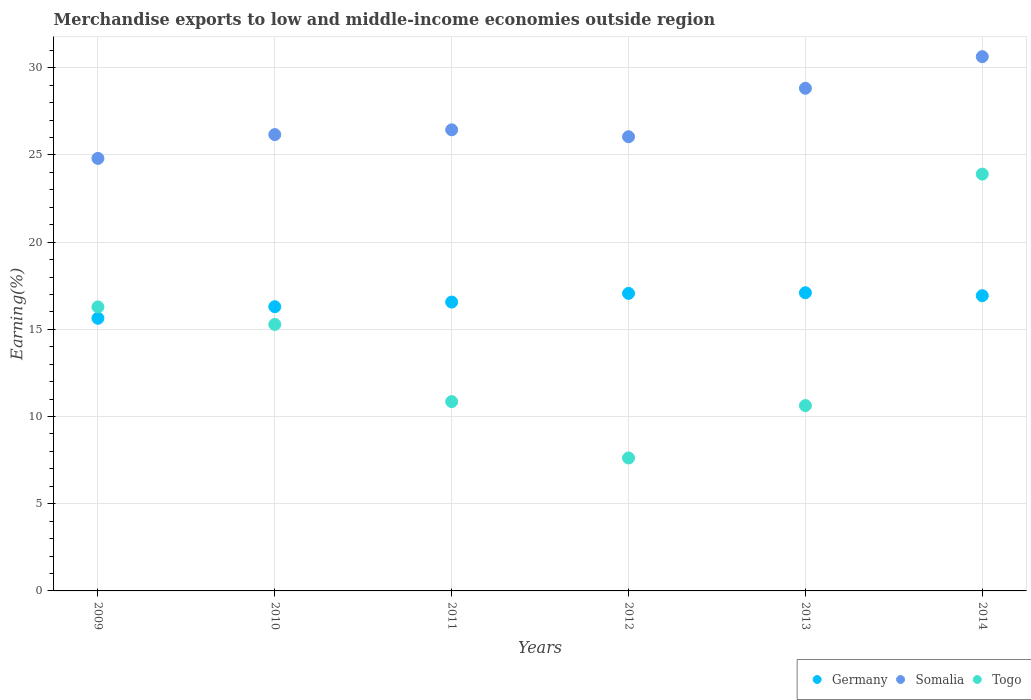How many different coloured dotlines are there?
Your answer should be very brief. 3. What is the percentage of amount earned from merchandise exports in Togo in 2012?
Your answer should be compact. 7.62. Across all years, what is the maximum percentage of amount earned from merchandise exports in Togo?
Give a very brief answer. 23.9. Across all years, what is the minimum percentage of amount earned from merchandise exports in Somalia?
Offer a very short reply. 24.8. In which year was the percentage of amount earned from merchandise exports in Somalia maximum?
Provide a short and direct response. 2014. In which year was the percentage of amount earned from merchandise exports in Togo minimum?
Provide a succinct answer. 2012. What is the total percentage of amount earned from merchandise exports in Somalia in the graph?
Give a very brief answer. 162.92. What is the difference between the percentage of amount earned from merchandise exports in Germany in 2010 and that in 2011?
Offer a terse response. -0.27. What is the difference between the percentage of amount earned from merchandise exports in Togo in 2014 and the percentage of amount earned from merchandise exports in Germany in 2012?
Make the answer very short. 6.84. What is the average percentage of amount earned from merchandise exports in Somalia per year?
Provide a short and direct response. 27.15. In the year 2009, what is the difference between the percentage of amount earned from merchandise exports in Germany and percentage of amount earned from merchandise exports in Togo?
Keep it short and to the point. -0.65. In how many years, is the percentage of amount earned from merchandise exports in Togo greater than 10 %?
Your answer should be very brief. 5. What is the ratio of the percentage of amount earned from merchandise exports in Germany in 2011 to that in 2013?
Ensure brevity in your answer.  0.97. Is the percentage of amount earned from merchandise exports in Germany in 2010 less than that in 2012?
Keep it short and to the point. Yes. Is the difference between the percentage of amount earned from merchandise exports in Germany in 2012 and 2013 greater than the difference between the percentage of amount earned from merchandise exports in Togo in 2012 and 2013?
Provide a short and direct response. Yes. What is the difference between the highest and the second highest percentage of amount earned from merchandise exports in Somalia?
Your answer should be compact. 1.81. What is the difference between the highest and the lowest percentage of amount earned from merchandise exports in Somalia?
Your response must be concise. 5.83. Is the sum of the percentage of amount earned from merchandise exports in Togo in 2010 and 2011 greater than the maximum percentage of amount earned from merchandise exports in Somalia across all years?
Provide a succinct answer. No. Is it the case that in every year, the sum of the percentage of amount earned from merchandise exports in Somalia and percentage of amount earned from merchandise exports in Germany  is greater than the percentage of amount earned from merchandise exports in Togo?
Give a very brief answer. Yes. Is the percentage of amount earned from merchandise exports in Germany strictly greater than the percentage of amount earned from merchandise exports in Somalia over the years?
Your answer should be compact. No. How many dotlines are there?
Your answer should be compact. 3. What is the difference between two consecutive major ticks on the Y-axis?
Ensure brevity in your answer.  5. Are the values on the major ticks of Y-axis written in scientific E-notation?
Your answer should be compact. No. Does the graph contain any zero values?
Provide a succinct answer. No. Does the graph contain grids?
Keep it short and to the point. Yes. Where does the legend appear in the graph?
Offer a terse response. Bottom right. What is the title of the graph?
Provide a succinct answer. Merchandise exports to low and middle-income economies outside region. What is the label or title of the Y-axis?
Provide a short and direct response. Earning(%). What is the Earning(%) of Germany in 2009?
Offer a very short reply. 15.63. What is the Earning(%) of Somalia in 2009?
Offer a terse response. 24.8. What is the Earning(%) of Togo in 2009?
Make the answer very short. 16.29. What is the Earning(%) in Germany in 2010?
Provide a succinct answer. 16.3. What is the Earning(%) of Somalia in 2010?
Give a very brief answer. 26.17. What is the Earning(%) of Togo in 2010?
Offer a terse response. 15.28. What is the Earning(%) in Germany in 2011?
Your response must be concise. 16.56. What is the Earning(%) of Somalia in 2011?
Make the answer very short. 26.44. What is the Earning(%) in Togo in 2011?
Make the answer very short. 10.85. What is the Earning(%) of Germany in 2012?
Offer a very short reply. 17.06. What is the Earning(%) in Somalia in 2012?
Ensure brevity in your answer.  26.04. What is the Earning(%) of Togo in 2012?
Ensure brevity in your answer.  7.62. What is the Earning(%) of Germany in 2013?
Provide a succinct answer. 17.1. What is the Earning(%) in Somalia in 2013?
Your answer should be very brief. 28.82. What is the Earning(%) of Togo in 2013?
Provide a short and direct response. 10.63. What is the Earning(%) of Germany in 2014?
Make the answer very short. 16.93. What is the Earning(%) in Somalia in 2014?
Keep it short and to the point. 30.64. What is the Earning(%) of Togo in 2014?
Give a very brief answer. 23.9. Across all years, what is the maximum Earning(%) in Germany?
Give a very brief answer. 17.1. Across all years, what is the maximum Earning(%) in Somalia?
Keep it short and to the point. 30.64. Across all years, what is the maximum Earning(%) in Togo?
Your response must be concise. 23.9. Across all years, what is the minimum Earning(%) of Germany?
Keep it short and to the point. 15.63. Across all years, what is the minimum Earning(%) in Somalia?
Provide a succinct answer. 24.8. Across all years, what is the minimum Earning(%) of Togo?
Offer a very short reply. 7.62. What is the total Earning(%) in Germany in the graph?
Give a very brief answer. 99.59. What is the total Earning(%) of Somalia in the graph?
Provide a short and direct response. 162.92. What is the total Earning(%) in Togo in the graph?
Offer a very short reply. 84.58. What is the difference between the Earning(%) in Germany in 2009 and that in 2010?
Your response must be concise. -0.66. What is the difference between the Earning(%) of Somalia in 2009 and that in 2010?
Offer a terse response. -1.37. What is the difference between the Earning(%) of Togo in 2009 and that in 2010?
Your response must be concise. 1. What is the difference between the Earning(%) of Germany in 2009 and that in 2011?
Offer a terse response. -0.93. What is the difference between the Earning(%) of Somalia in 2009 and that in 2011?
Make the answer very short. -1.64. What is the difference between the Earning(%) in Togo in 2009 and that in 2011?
Offer a terse response. 5.43. What is the difference between the Earning(%) in Germany in 2009 and that in 2012?
Make the answer very short. -1.43. What is the difference between the Earning(%) of Somalia in 2009 and that in 2012?
Provide a succinct answer. -1.24. What is the difference between the Earning(%) of Togo in 2009 and that in 2012?
Offer a very short reply. 8.66. What is the difference between the Earning(%) in Germany in 2009 and that in 2013?
Keep it short and to the point. -1.46. What is the difference between the Earning(%) in Somalia in 2009 and that in 2013?
Ensure brevity in your answer.  -4.02. What is the difference between the Earning(%) in Togo in 2009 and that in 2013?
Ensure brevity in your answer.  5.66. What is the difference between the Earning(%) in Germany in 2009 and that in 2014?
Offer a very short reply. -1.3. What is the difference between the Earning(%) in Somalia in 2009 and that in 2014?
Keep it short and to the point. -5.83. What is the difference between the Earning(%) in Togo in 2009 and that in 2014?
Ensure brevity in your answer.  -7.61. What is the difference between the Earning(%) of Germany in 2010 and that in 2011?
Provide a succinct answer. -0.27. What is the difference between the Earning(%) in Somalia in 2010 and that in 2011?
Keep it short and to the point. -0.27. What is the difference between the Earning(%) of Togo in 2010 and that in 2011?
Provide a succinct answer. 4.43. What is the difference between the Earning(%) in Germany in 2010 and that in 2012?
Your response must be concise. -0.76. What is the difference between the Earning(%) in Somalia in 2010 and that in 2012?
Offer a very short reply. 0.12. What is the difference between the Earning(%) of Togo in 2010 and that in 2012?
Provide a short and direct response. 7.66. What is the difference between the Earning(%) in Germany in 2010 and that in 2013?
Offer a very short reply. -0.8. What is the difference between the Earning(%) of Somalia in 2010 and that in 2013?
Your response must be concise. -2.66. What is the difference between the Earning(%) in Togo in 2010 and that in 2013?
Give a very brief answer. 4.65. What is the difference between the Earning(%) of Germany in 2010 and that in 2014?
Ensure brevity in your answer.  -0.63. What is the difference between the Earning(%) of Somalia in 2010 and that in 2014?
Provide a short and direct response. -4.47. What is the difference between the Earning(%) of Togo in 2010 and that in 2014?
Make the answer very short. -8.62. What is the difference between the Earning(%) of Germany in 2011 and that in 2012?
Ensure brevity in your answer.  -0.5. What is the difference between the Earning(%) in Somalia in 2011 and that in 2012?
Offer a terse response. 0.4. What is the difference between the Earning(%) of Togo in 2011 and that in 2012?
Your answer should be very brief. 3.23. What is the difference between the Earning(%) in Germany in 2011 and that in 2013?
Ensure brevity in your answer.  -0.54. What is the difference between the Earning(%) of Somalia in 2011 and that in 2013?
Provide a short and direct response. -2.38. What is the difference between the Earning(%) in Togo in 2011 and that in 2013?
Your answer should be very brief. 0.23. What is the difference between the Earning(%) of Germany in 2011 and that in 2014?
Your answer should be very brief. -0.37. What is the difference between the Earning(%) of Somalia in 2011 and that in 2014?
Make the answer very short. -4.2. What is the difference between the Earning(%) of Togo in 2011 and that in 2014?
Offer a very short reply. -13.05. What is the difference between the Earning(%) of Germany in 2012 and that in 2013?
Your answer should be compact. -0.04. What is the difference between the Earning(%) of Somalia in 2012 and that in 2013?
Ensure brevity in your answer.  -2.78. What is the difference between the Earning(%) in Togo in 2012 and that in 2013?
Make the answer very short. -3.01. What is the difference between the Earning(%) of Germany in 2012 and that in 2014?
Provide a short and direct response. 0.13. What is the difference between the Earning(%) in Somalia in 2012 and that in 2014?
Your answer should be very brief. -4.59. What is the difference between the Earning(%) of Togo in 2012 and that in 2014?
Your answer should be compact. -16.28. What is the difference between the Earning(%) of Germany in 2013 and that in 2014?
Your answer should be very brief. 0.17. What is the difference between the Earning(%) of Somalia in 2013 and that in 2014?
Give a very brief answer. -1.81. What is the difference between the Earning(%) of Togo in 2013 and that in 2014?
Provide a succinct answer. -13.27. What is the difference between the Earning(%) of Germany in 2009 and the Earning(%) of Somalia in 2010?
Your response must be concise. -10.53. What is the difference between the Earning(%) of Germany in 2009 and the Earning(%) of Togo in 2010?
Your answer should be very brief. 0.35. What is the difference between the Earning(%) of Somalia in 2009 and the Earning(%) of Togo in 2010?
Your answer should be very brief. 9.52. What is the difference between the Earning(%) in Germany in 2009 and the Earning(%) in Somalia in 2011?
Give a very brief answer. -10.81. What is the difference between the Earning(%) of Germany in 2009 and the Earning(%) of Togo in 2011?
Your answer should be very brief. 4.78. What is the difference between the Earning(%) of Somalia in 2009 and the Earning(%) of Togo in 2011?
Give a very brief answer. 13.95. What is the difference between the Earning(%) of Germany in 2009 and the Earning(%) of Somalia in 2012?
Ensure brevity in your answer.  -10.41. What is the difference between the Earning(%) of Germany in 2009 and the Earning(%) of Togo in 2012?
Make the answer very short. 8.01. What is the difference between the Earning(%) in Somalia in 2009 and the Earning(%) in Togo in 2012?
Offer a very short reply. 17.18. What is the difference between the Earning(%) in Germany in 2009 and the Earning(%) in Somalia in 2013?
Ensure brevity in your answer.  -13.19. What is the difference between the Earning(%) of Germany in 2009 and the Earning(%) of Togo in 2013?
Provide a succinct answer. 5.01. What is the difference between the Earning(%) in Somalia in 2009 and the Earning(%) in Togo in 2013?
Keep it short and to the point. 14.17. What is the difference between the Earning(%) in Germany in 2009 and the Earning(%) in Somalia in 2014?
Offer a very short reply. -15. What is the difference between the Earning(%) of Germany in 2009 and the Earning(%) of Togo in 2014?
Provide a succinct answer. -8.27. What is the difference between the Earning(%) in Somalia in 2009 and the Earning(%) in Togo in 2014?
Provide a short and direct response. 0.9. What is the difference between the Earning(%) of Germany in 2010 and the Earning(%) of Somalia in 2011?
Ensure brevity in your answer.  -10.14. What is the difference between the Earning(%) of Germany in 2010 and the Earning(%) of Togo in 2011?
Your answer should be very brief. 5.44. What is the difference between the Earning(%) of Somalia in 2010 and the Earning(%) of Togo in 2011?
Your answer should be very brief. 15.31. What is the difference between the Earning(%) of Germany in 2010 and the Earning(%) of Somalia in 2012?
Make the answer very short. -9.75. What is the difference between the Earning(%) of Germany in 2010 and the Earning(%) of Togo in 2012?
Offer a very short reply. 8.67. What is the difference between the Earning(%) in Somalia in 2010 and the Earning(%) in Togo in 2012?
Your answer should be compact. 18.54. What is the difference between the Earning(%) of Germany in 2010 and the Earning(%) of Somalia in 2013?
Your response must be concise. -12.53. What is the difference between the Earning(%) of Germany in 2010 and the Earning(%) of Togo in 2013?
Provide a succinct answer. 5.67. What is the difference between the Earning(%) of Somalia in 2010 and the Earning(%) of Togo in 2013?
Offer a terse response. 15.54. What is the difference between the Earning(%) in Germany in 2010 and the Earning(%) in Somalia in 2014?
Your response must be concise. -14.34. What is the difference between the Earning(%) in Germany in 2010 and the Earning(%) in Togo in 2014?
Keep it short and to the point. -7.6. What is the difference between the Earning(%) of Somalia in 2010 and the Earning(%) of Togo in 2014?
Ensure brevity in your answer.  2.27. What is the difference between the Earning(%) of Germany in 2011 and the Earning(%) of Somalia in 2012?
Give a very brief answer. -9.48. What is the difference between the Earning(%) in Germany in 2011 and the Earning(%) in Togo in 2012?
Offer a terse response. 8.94. What is the difference between the Earning(%) of Somalia in 2011 and the Earning(%) of Togo in 2012?
Your answer should be very brief. 18.82. What is the difference between the Earning(%) of Germany in 2011 and the Earning(%) of Somalia in 2013?
Give a very brief answer. -12.26. What is the difference between the Earning(%) in Germany in 2011 and the Earning(%) in Togo in 2013?
Offer a very short reply. 5.93. What is the difference between the Earning(%) in Somalia in 2011 and the Earning(%) in Togo in 2013?
Your response must be concise. 15.81. What is the difference between the Earning(%) in Germany in 2011 and the Earning(%) in Somalia in 2014?
Give a very brief answer. -14.07. What is the difference between the Earning(%) in Germany in 2011 and the Earning(%) in Togo in 2014?
Make the answer very short. -7.34. What is the difference between the Earning(%) of Somalia in 2011 and the Earning(%) of Togo in 2014?
Offer a very short reply. 2.54. What is the difference between the Earning(%) in Germany in 2012 and the Earning(%) in Somalia in 2013?
Give a very brief answer. -11.76. What is the difference between the Earning(%) of Germany in 2012 and the Earning(%) of Togo in 2013?
Provide a short and direct response. 6.43. What is the difference between the Earning(%) in Somalia in 2012 and the Earning(%) in Togo in 2013?
Your response must be concise. 15.42. What is the difference between the Earning(%) of Germany in 2012 and the Earning(%) of Somalia in 2014?
Give a very brief answer. -13.58. What is the difference between the Earning(%) of Germany in 2012 and the Earning(%) of Togo in 2014?
Provide a short and direct response. -6.84. What is the difference between the Earning(%) of Somalia in 2012 and the Earning(%) of Togo in 2014?
Give a very brief answer. 2.14. What is the difference between the Earning(%) in Germany in 2013 and the Earning(%) in Somalia in 2014?
Your response must be concise. -13.54. What is the difference between the Earning(%) of Germany in 2013 and the Earning(%) of Togo in 2014?
Give a very brief answer. -6.8. What is the difference between the Earning(%) of Somalia in 2013 and the Earning(%) of Togo in 2014?
Your answer should be very brief. 4.92. What is the average Earning(%) of Germany per year?
Keep it short and to the point. 16.6. What is the average Earning(%) in Somalia per year?
Your answer should be very brief. 27.15. What is the average Earning(%) of Togo per year?
Your answer should be very brief. 14.1. In the year 2009, what is the difference between the Earning(%) in Germany and Earning(%) in Somalia?
Provide a succinct answer. -9.17. In the year 2009, what is the difference between the Earning(%) of Germany and Earning(%) of Togo?
Your answer should be very brief. -0.65. In the year 2009, what is the difference between the Earning(%) in Somalia and Earning(%) in Togo?
Ensure brevity in your answer.  8.52. In the year 2010, what is the difference between the Earning(%) in Germany and Earning(%) in Somalia?
Offer a terse response. -9.87. In the year 2010, what is the difference between the Earning(%) of Germany and Earning(%) of Togo?
Offer a terse response. 1.02. In the year 2010, what is the difference between the Earning(%) of Somalia and Earning(%) of Togo?
Your response must be concise. 10.89. In the year 2011, what is the difference between the Earning(%) of Germany and Earning(%) of Somalia?
Provide a short and direct response. -9.88. In the year 2011, what is the difference between the Earning(%) in Germany and Earning(%) in Togo?
Your answer should be compact. 5.71. In the year 2011, what is the difference between the Earning(%) in Somalia and Earning(%) in Togo?
Offer a terse response. 15.59. In the year 2012, what is the difference between the Earning(%) in Germany and Earning(%) in Somalia?
Make the answer very short. -8.98. In the year 2012, what is the difference between the Earning(%) of Germany and Earning(%) of Togo?
Offer a terse response. 9.44. In the year 2012, what is the difference between the Earning(%) of Somalia and Earning(%) of Togo?
Your response must be concise. 18.42. In the year 2013, what is the difference between the Earning(%) of Germany and Earning(%) of Somalia?
Provide a succinct answer. -11.72. In the year 2013, what is the difference between the Earning(%) in Germany and Earning(%) in Togo?
Your answer should be compact. 6.47. In the year 2013, what is the difference between the Earning(%) of Somalia and Earning(%) of Togo?
Your answer should be very brief. 18.19. In the year 2014, what is the difference between the Earning(%) of Germany and Earning(%) of Somalia?
Ensure brevity in your answer.  -13.71. In the year 2014, what is the difference between the Earning(%) in Germany and Earning(%) in Togo?
Ensure brevity in your answer.  -6.97. In the year 2014, what is the difference between the Earning(%) in Somalia and Earning(%) in Togo?
Give a very brief answer. 6.74. What is the ratio of the Earning(%) in Germany in 2009 to that in 2010?
Offer a very short reply. 0.96. What is the ratio of the Earning(%) in Somalia in 2009 to that in 2010?
Provide a succinct answer. 0.95. What is the ratio of the Earning(%) in Togo in 2009 to that in 2010?
Your answer should be very brief. 1.07. What is the ratio of the Earning(%) of Germany in 2009 to that in 2011?
Keep it short and to the point. 0.94. What is the ratio of the Earning(%) of Somalia in 2009 to that in 2011?
Give a very brief answer. 0.94. What is the ratio of the Earning(%) of Togo in 2009 to that in 2011?
Ensure brevity in your answer.  1.5. What is the ratio of the Earning(%) of Germany in 2009 to that in 2012?
Provide a succinct answer. 0.92. What is the ratio of the Earning(%) of Somalia in 2009 to that in 2012?
Provide a succinct answer. 0.95. What is the ratio of the Earning(%) in Togo in 2009 to that in 2012?
Offer a terse response. 2.14. What is the ratio of the Earning(%) in Germany in 2009 to that in 2013?
Keep it short and to the point. 0.91. What is the ratio of the Earning(%) of Somalia in 2009 to that in 2013?
Make the answer very short. 0.86. What is the ratio of the Earning(%) in Togo in 2009 to that in 2013?
Provide a short and direct response. 1.53. What is the ratio of the Earning(%) of Germany in 2009 to that in 2014?
Ensure brevity in your answer.  0.92. What is the ratio of the Earning(%) of Somalia in 2009 to that in 2014?
Your answer should be very brief. 0.81. What is the ratio of the Earning(%) in Togo in 2009 to that in 2014?
Provide a succinct answer. 0.68. What is the ratio of the Earning(%) of Germany in 2010 to that in 2011?
Your response must be concise. 0.98. What is the ratio of the Earning(%) of Somalia in 2010 to that in 2011?
Your response must be concise. 0.99. What is the ratio of the Earning(%) of Togo in 2010 to that in 2011?
Keep it short and to the point. 1.41. What is the ratio of the Earning(%) of Germany in 2010 to that in 2012?
Your answer should be compact. 0.96. What is the ratio of the Earning(%) of Togo in 2010 to that in 2012?
Offer a very short reply. 2. What is the ratio of the Earning(%) of Germany in 2010 to that in 2013?
Provide a short and direct response. 0.95. What is the ratio of the Earning(%) of Somalia in 2010 to that in 2013?
Provide a short and direct response. 0.91. What is the ratio of the Earning(%) of Togo in 2010 to that in 2013?
Provide a succinct answer. 1.44. What is the ratio of the Earning(%) in Germany in 2010 to that in 2014?
Make the answer very short. 0.96. What is the ratio of the Earning(%) of Somalia in 2010 to that in 2014?
Provide a short and direct response. 0.85. What is the ratio of the Earning(%) in Togo in 2010 to that in 2014?
Keep it short and to the point. 0.64. What is the ratio of the Earning(%) in Germany in 2011 to that in 2012?
Give a very brief answer. 0.97. What is the ratio of the Earning(%) in Somalia in 2011 to that in 2012?
Give a very brief answer. 1.02. What is the ratio of the Earning(%) of Togo in 2011 to that in 2012?
Ensure brevity in your answer.  1.42. What is the ratio of the Earning(%) in Germany in 2011 to that in 2013?
Make the answer very short. 0.97. What is the ratio of the Earning(%) in Somalia in 2011 to that in 2013?
Make the answer very short. 0.92. What is the ratio of the Earning(%) in Togo in 2011 to that in 2013?
Your response must be concise. 1.02. What is the ratio of the Earning(%) in Germany in 2011 to that in 2014?
Give a very brief answer. 0.98. What is the ratio of the Earning(%) of Somalia in 2011 to that in 2014?
Your answer should be very brief. 0.86. What is the ratio of the Earning(%) in Togo in 2011 to that in 2014?
Make the answer very short. 0.45. What is the ratio of the Earning(%) in Germany in 2012 to that in 2013?
Your answer should be compact. 1. What is the ratio of the Earning(%) of Somalia in 2012 to that in 2013?
Offer a very short reply. 0.9. What is the ratio of the Earning(%) in Togo in 2012 to that in 2013?
Your response must be concise. 0.72. What is the ratio of the Earning(%) in Germany in 2012 to that in 2014?
Ensure brevity in your answer.  1.01. What is the ratio of the Earning(%) in Somalia in 2012 to that in 2014?
Make the answer very short. 0.85. What is the ratio of the Earning(%) of Togo in 2012 to that in 2014?
Keep it short and to the point. 0.32. What is the ratio of the Earning(%) in Germany in 2013 to that in 2014?
Ensure brevity in your answer.  1.01. What is the ratio of the Earning(%) in Somalia in 2013 to that in 2014?
Ensure brevity in your answer.  0.94. What is the ratio of the Earning(%) of Togo in 2013 to that in 2014?
Provide a short and direct response. 0.44. What is the difference between the highest and the second highest Earning(%) in Germany?
Provide a succinct answer. 0.04. What is the difference between the highest and the second highest Earning(%) in Somalia?
Offer a very short reply. 1.81. What is the difference between the highest and the second highest Earning(%) in Togo?
Offer a very short reply. 7.61. What is the difference between the highest and the lowest Earning(%) of Germany?
Ensure brevity in your answer.  1.46. What is the difference between the highest and the lowest Earning(%) of Somalia?
Give a very brief answer. 5.83. What is the difference between the highest and the lowest Earning(%) of Togo?
Your answer should be compact. 16.28. 